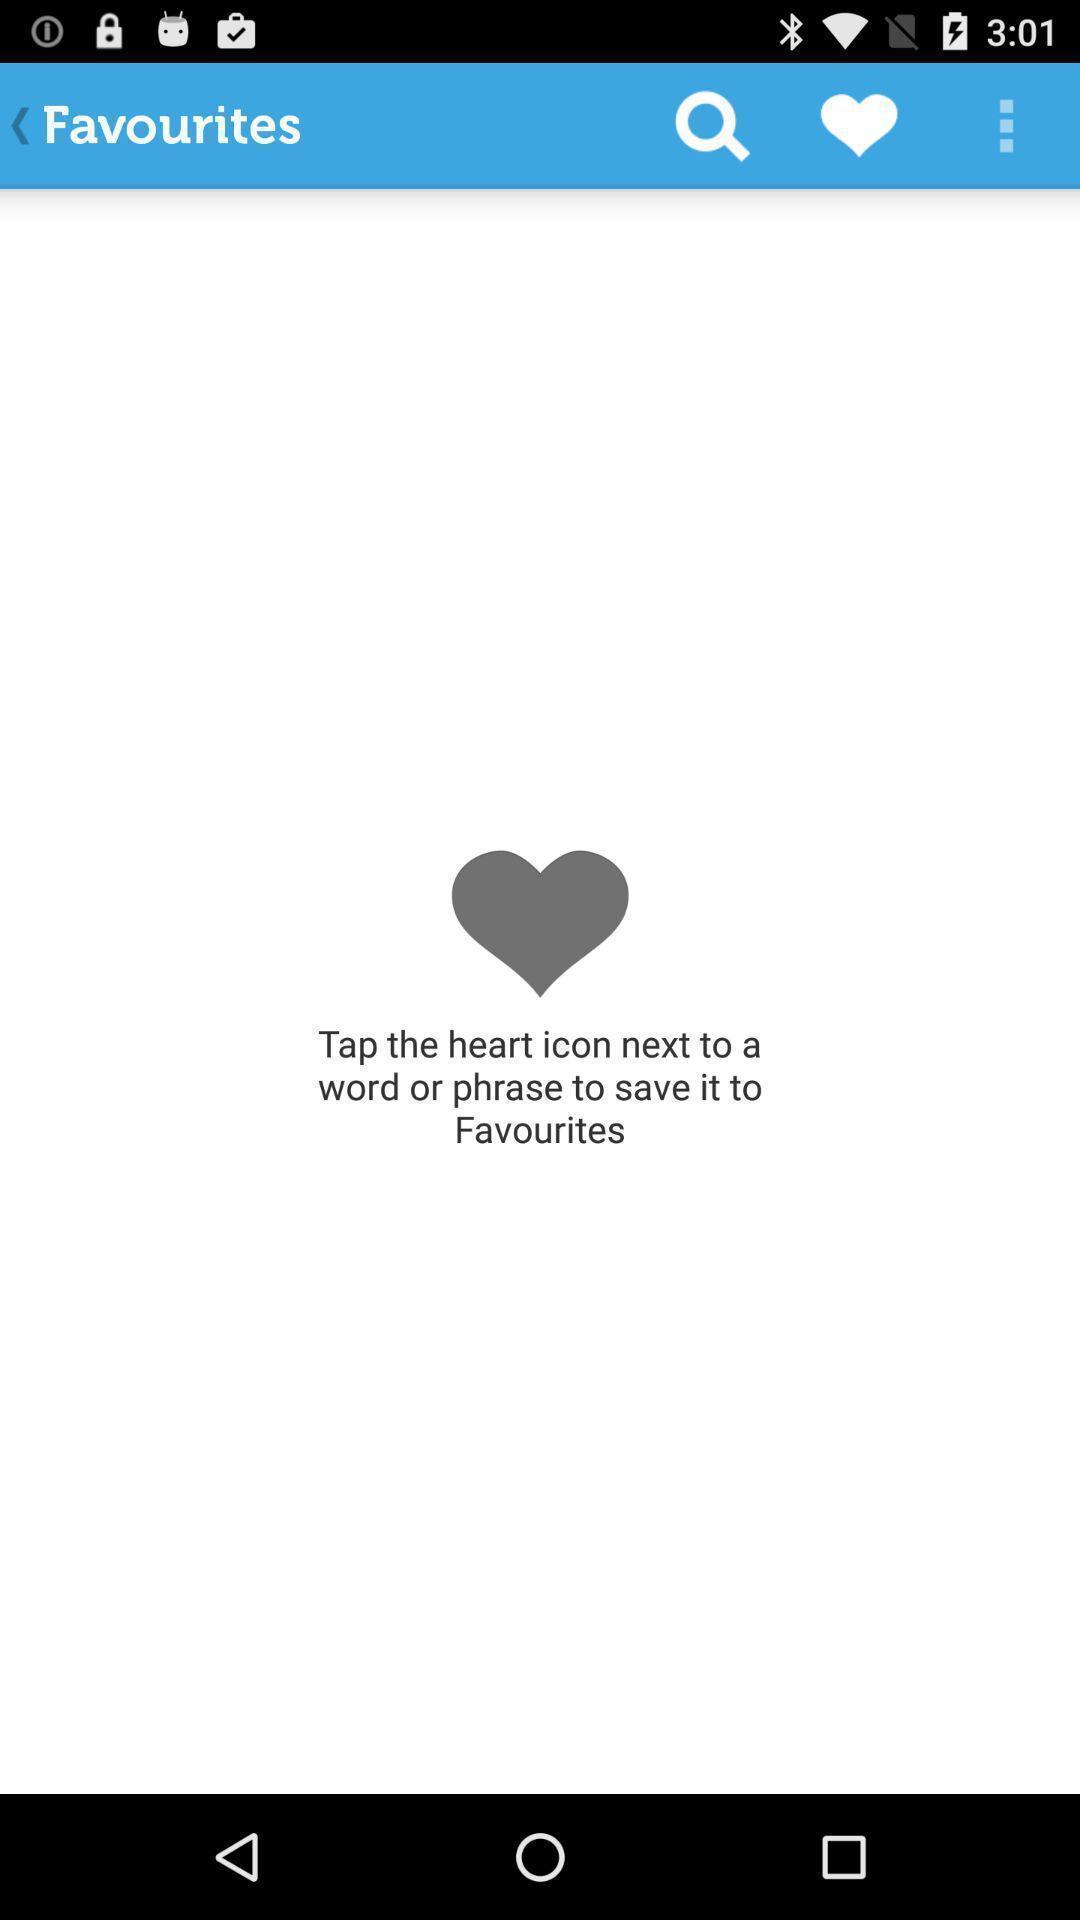Explain what's happening in this screen capture. Screen shows favourites. 